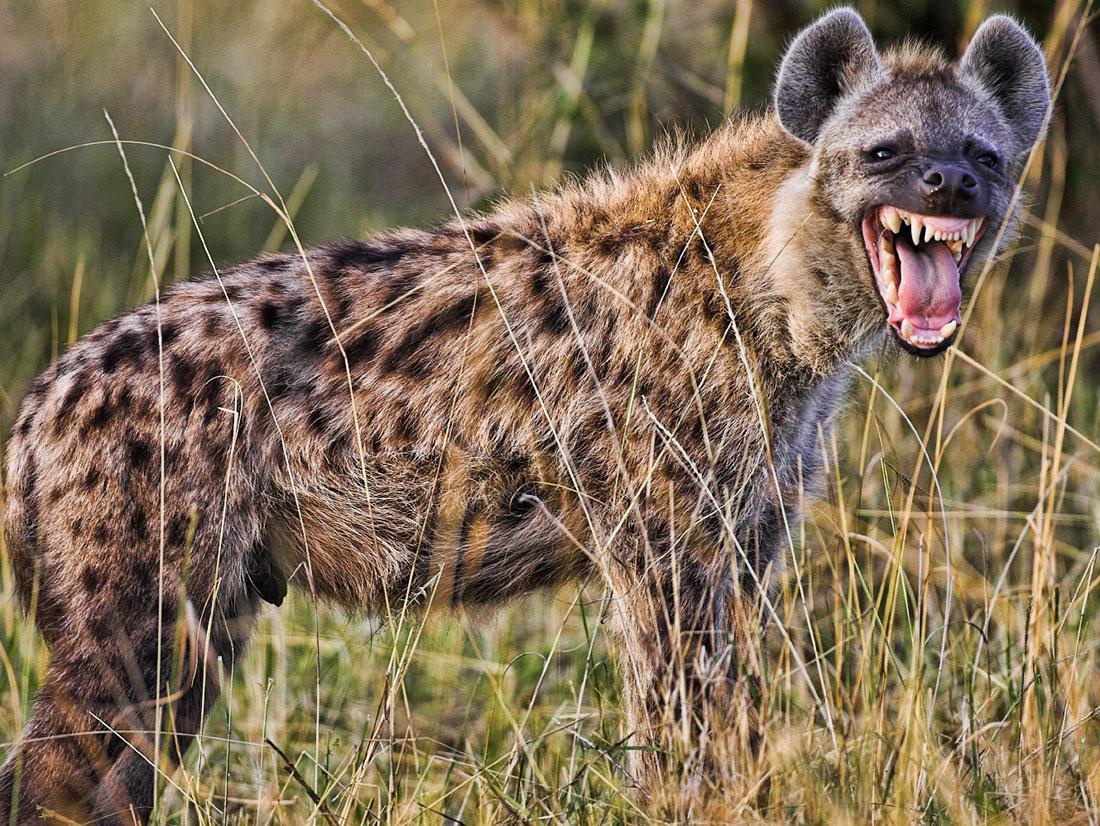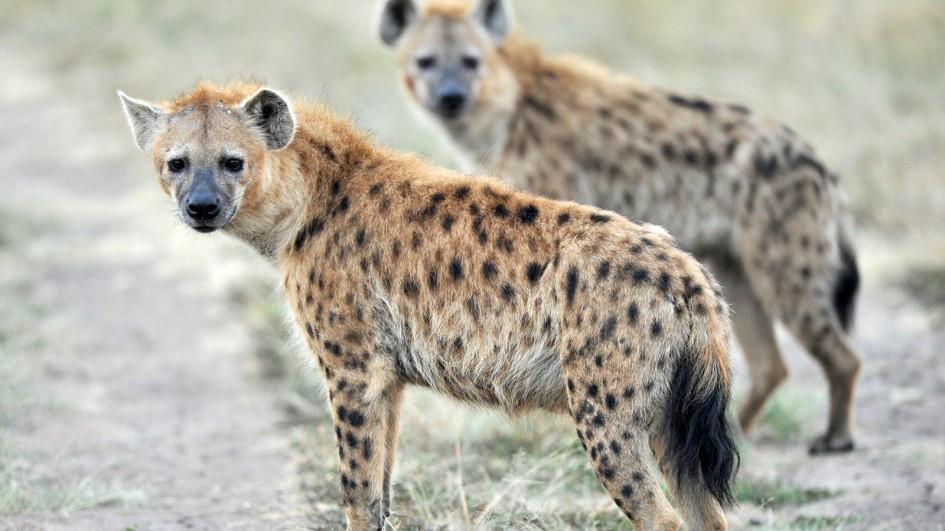The first image is the image on the left, the second image is the image on the right. Considering the images on both sides, is "A hyena has its mouth wide open" valid? Answer yes or no. Yes. 